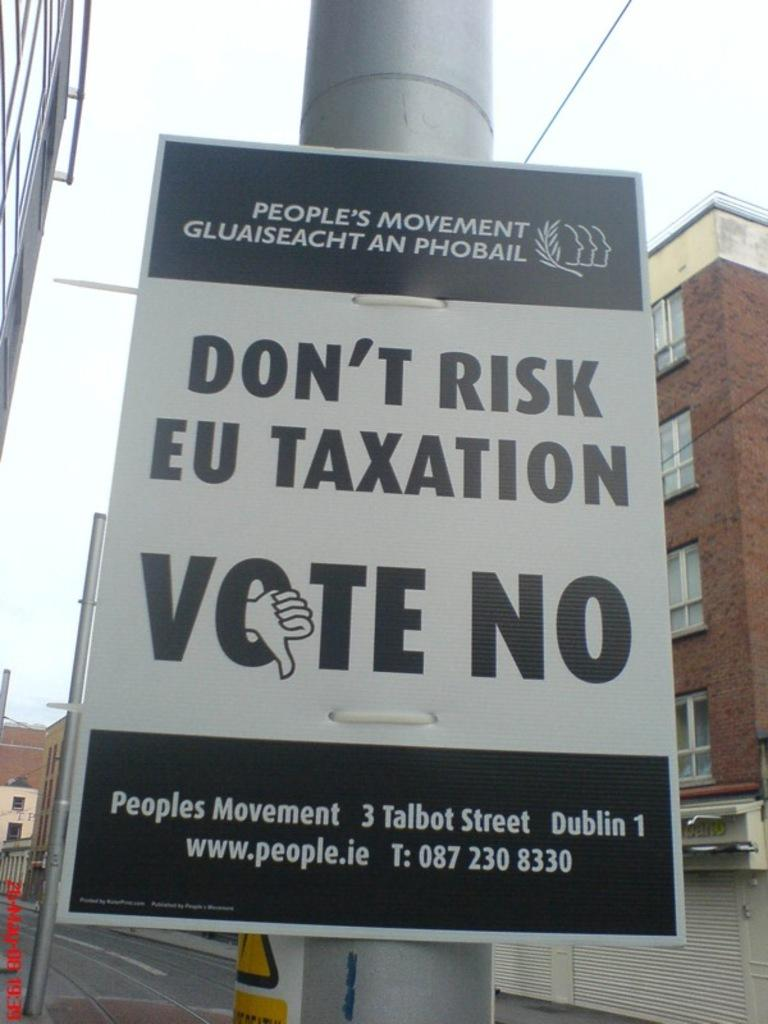<image>
Write a terse but informative summary of the picture. A political sign urging people to vote no 